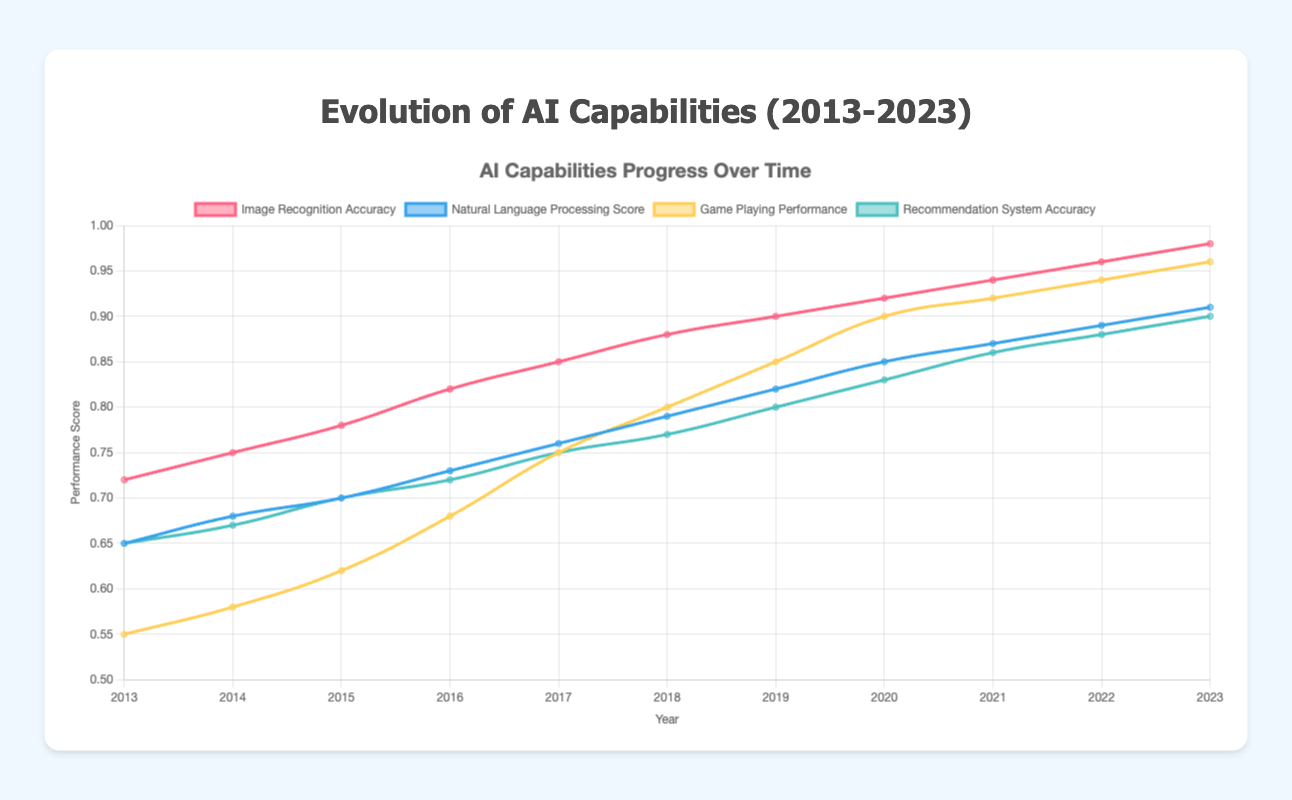What's the trend in image recognition accuracy over the ten years? The trend shows a consistent increase in the image recognition accuracy from 0.72 in 2013 to 0.98 in 2023. There are no drops, and the growth seems steady.
Answer: Consistently increasing Which year had the highest game-playing performance? By observing the line labeled 'Game Playing Performance', the peak value is reached in the year 2023, with a performance score of 0.96.
Answer: 2023 Between 2016 and 2018, was there an increase or decrease in autonomous driving miles without intervention, and by how much? In 2016, the autonomous driving miles were 3000, and in 2018, it was 6000. The difference between these values is 6000 - 3000 = 3000 miles indicating an increase.
Answer: Increase by 3000 miles Compare the natural language processing score and the recommendation system accuracy in 2016. Which one is higher and by how much? For 2016, the natural language processing score is 0.73, while recommendation system accuracy is 0.72. The difference is 0.73 - 0.72 = 0.01. Thus, the natural language processing score is higher by 0.01.
Answer: Natural language processing score by 0.01 What's the visual difference between the line representing the game playing performance and the recommendation system accuracy? The game-playing performance line is colored yellow (or a shade of it) while the recommendation system accuracy line is colored blue (or a shade of it). Differently colored lines help delineate each dataset.
Answer: Yellow for game-playing, Blue for recommendation In which year did the image recognition accuracy and natural language processing score both surpass 0.9? Checking the lines, both the image recognition accuracy and natural language processing score data surpass 0.9 only in 2023.
Answer: 2023 From 2013 to 2023, what is the total increase in recommendation system accuracy? Recommendation system accuracy was 0.65 in 2013 and increased to 0.90 in 2023. The total increase is 0.90 - 0.65 = 0.25.
Answer: 0.25 Which year saw the largest single-year increase in autonomous driving miles without intervention? By inspecting the curve, the largest increase occurs between 2019 and 2020, where the value jumps from 8000 to 12000, a difference of 4000 miles.
Answer: 2019-2020 Identify the year where natural language processing made its first reach past 80% accuracy. The year the natural language processing score first exceeds 0.80 (which is 80%) is 2019 when it reached 0.82.
Answer: 2019 Calculate the average recommendation system accuracy from 2013 to 2023. Sum the values from 2013 to 2023 and divide by the number of years: (0.65 + 0.67 + 0.70 + 0.72 + 0.75 + 0.77 + 0.80 + 0.83 + 0.86 + 0.88 + 0.90) / 11 = 8.33 / 11 = 0.757 (rounded to three decimal places).
Answer: 0.757 